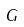Convert formula to latex. <formula><loc_0><loc_0><loc_500><loc_500>G</formula> 